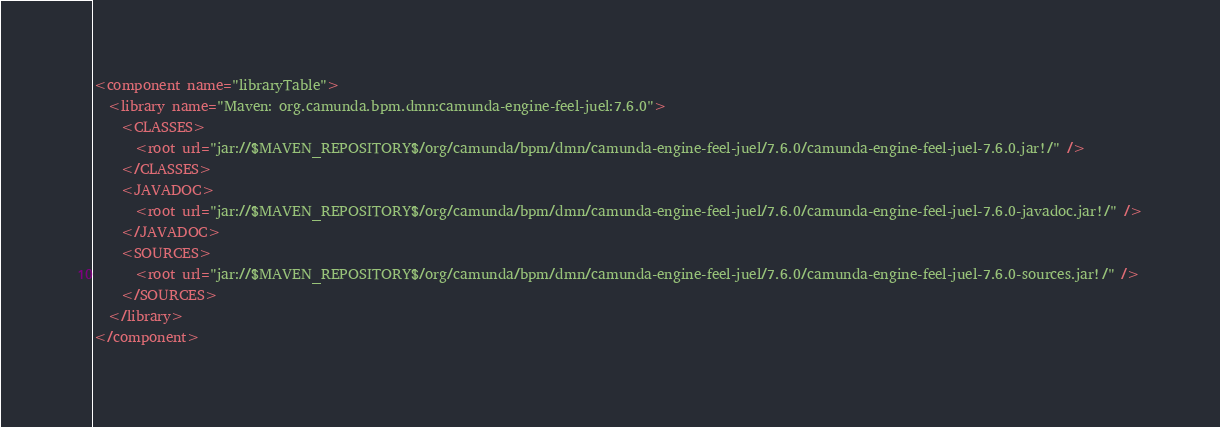<code> <loc_0><loc_0><loc_500><loc_500><_XML_><component name="libraryTable">
  <library name="Maven: org.camunda.bpm.dmn:camunda-engine-feel-juel:7.6.0">
    <CLASSES>
      <root url="jar://$MAVEN_REPOSITORY$/org/camunda/bpm/dmn/camunda-engine-feel-juel/7.6.0/camunda-engine-feel-juel-7.6.0.jar!/" />
    </CLASSES>
    <JAVADOC>
      <root url="jar://$MAVEN_REPOSITORY$/org/camunda/bpm/dmn/camunda-engine-feel-juel/7.6.0/camunda-engine-feel-juel-7.6.0-javadoc.jar!/" />
    </JAVADOC>
    <SOURCES>
      <root url="jar://$MAVEN_REPOSITORY$/org/camunda/bpm/dmn/camunda-engine-feel-juel/7.6.0/camunda-engine-feel-juel-7.6.0-sources.jar!/" />
    </SOURCES>
  </library>
</component></code> 